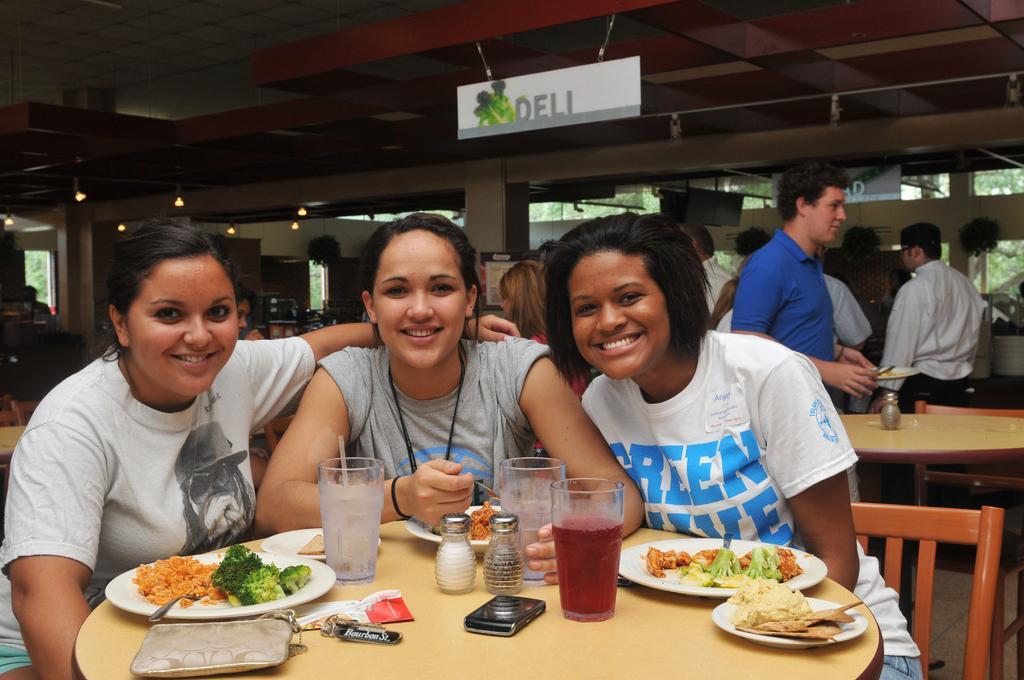Describe this image in one or two sentences. This is the picture of three people who is sitting in the chair in front a table and on the table we have some food items, jars, glasses and behind there are some people standing. 